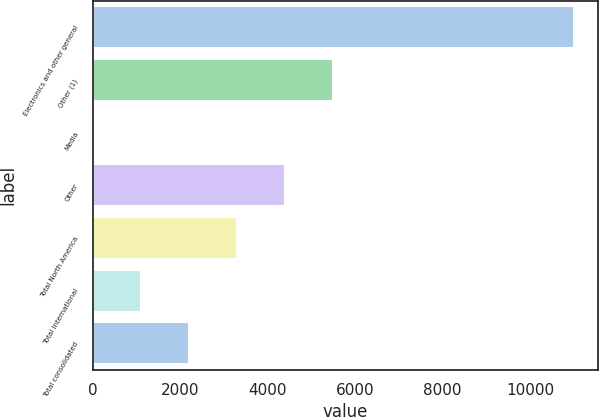Convert chart to OTSL. <chart><loc_0><loc_0><loc_500><loc_500><bar_chart><fcel>Electronics and other general<fcel>Other (1)<fcel>Media<fcel>Other<fcel>Total North America<fcel>Total International<fcel>Total consolidated<nl><fcel>10998<fcel>5506.5<fcel>15<fcel>4408.2<fcel>3309.9<fcel>1113.3<fcel>2211.6<nl></chart> 